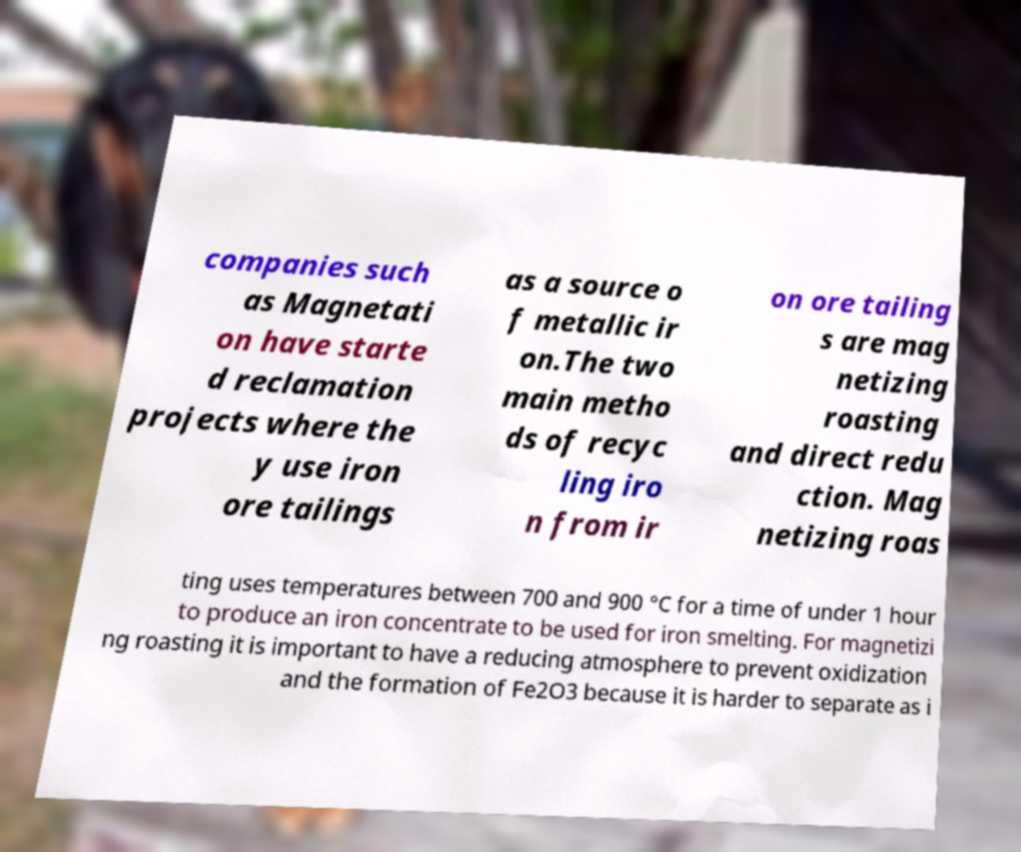Could you extract and type out the text from this image? companies such as Magnetati on have starte d reclamation projects where the y use iron ore tailings as a source o f metallic ir on.The two main metho ds of recyc ling iro n from ir on ore tailing s are mag netizing roasting and direct redu ction. Mag netizing roas ting uses temperatures between 700 and 900 °C for a time of under 1 hour to produce an iron concentrate to be used for iron smelting. For magnetizi ng roasting it is important to have a reducing atmosphere to prevent oxidization and the formation of Fe2O3 because it is harder to separate as i 